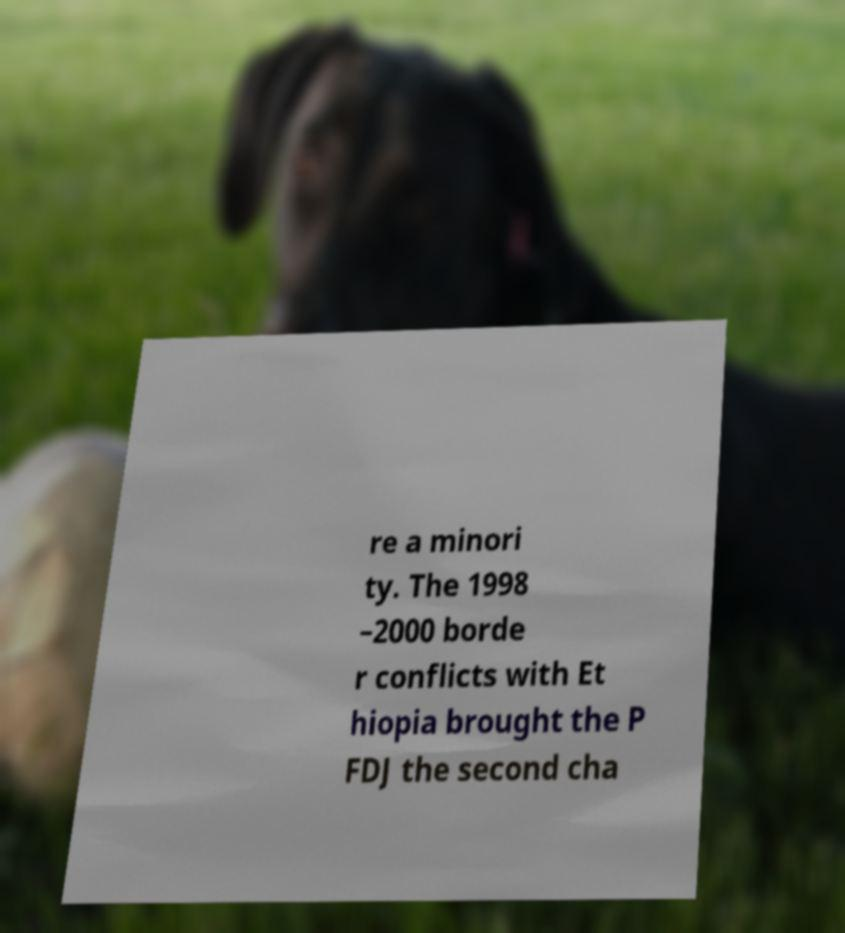There's text embedded in this image that I need extracted. Can you transcribe it verbatim? re a minori ty. The 1998 –2000 borde r conflicts with Et hiopia brought the P FDJ the second cha 